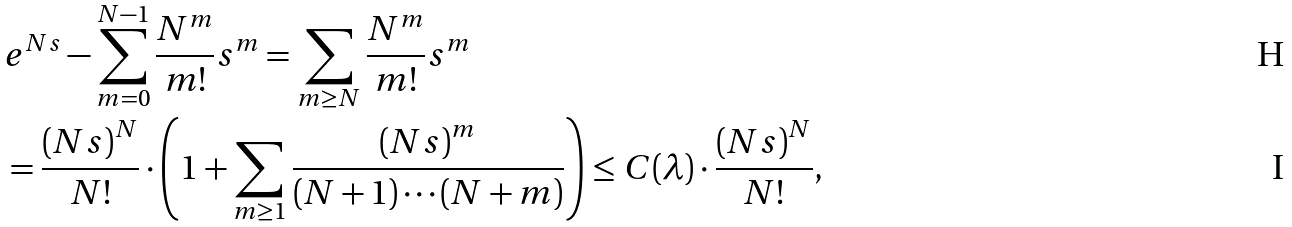<formula> <loc_0><loc_0><loc_500><loc_500>& e ^ { N s } - \sum _ { m = 0 } ^ { N - 1 } \frac { N ^ { m } } { m ! } { s } ^ { m } = \sum _ { m \geq N } \frac { N ^ { m } } { m ! } { s } ^ { m } \\ & = \frac { { ( N s ) } ^ { N } } { N ! } \cdot \left ( 1 + \sum _ { m \geq 1 } \frac { { ( N s ) } ^ { m } } { ( N + 1 ) \cdots ( N + m ) } \right ) \leq C ( \lambda ) \cdot \frac { { ( N s ) } ^ { N } } { N ! } ,</formula> 